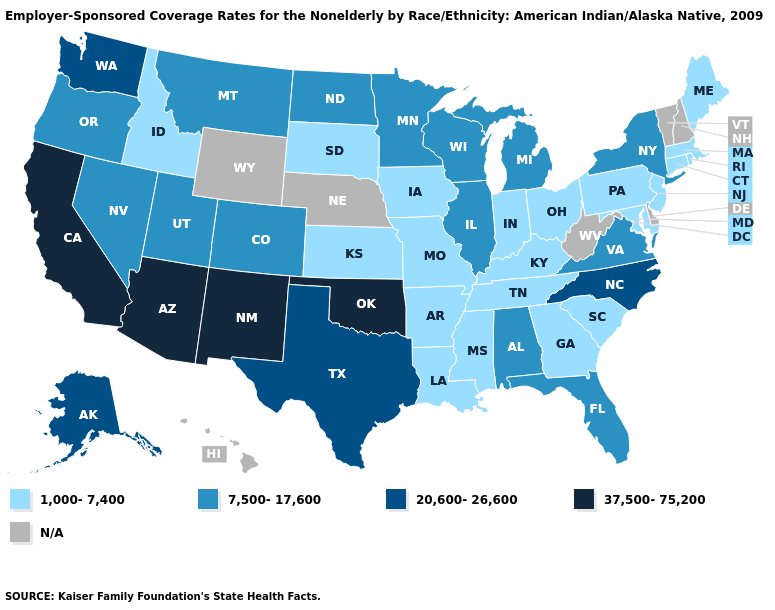How many symbols are there in the legend?
Keep it brief. 5. What is the value of Oregon?
Concise answer only. 7,500-17,600. Does the first symbol in the legend represent the smallest category?
Give a very brief answer. Yes. Among the states that border Washington , which have the highest value?
Give a very brief answer. Oregon. What is the value of Nevada?
Concise answer only. 7,500-17,600. Among the states that border Massachusetts , which have the lowest value?
Give a very brief answer. Connecticut, Rhode Island. Does the map have missing data?
Be succinct. Yes. Which states have the lowest value in the West?
Write a very short answer. Idaho. What is the highest value in the USA?
Concise answer only. 37,500-75,200. What is the highest value in the South ?
Answer briefly. 37,500-75,200. Does Utah have the lowest value in the USA?
Be succinct. No. What is the lowest value in the USA?
Write a very short answer. 1,000-7,400. Among the states that border Tennessee , does Virginia have the highest value?
Be succinct. No. Name the states that have a value in the range 37,500-75,200?
Give a very brief answer. Arizona, California, New Mexico, Oklahoma. Name the states that have a value in the range 37,500-75,200?
Be succinct. Arizona, California, New Mexico, Oklahoma. 